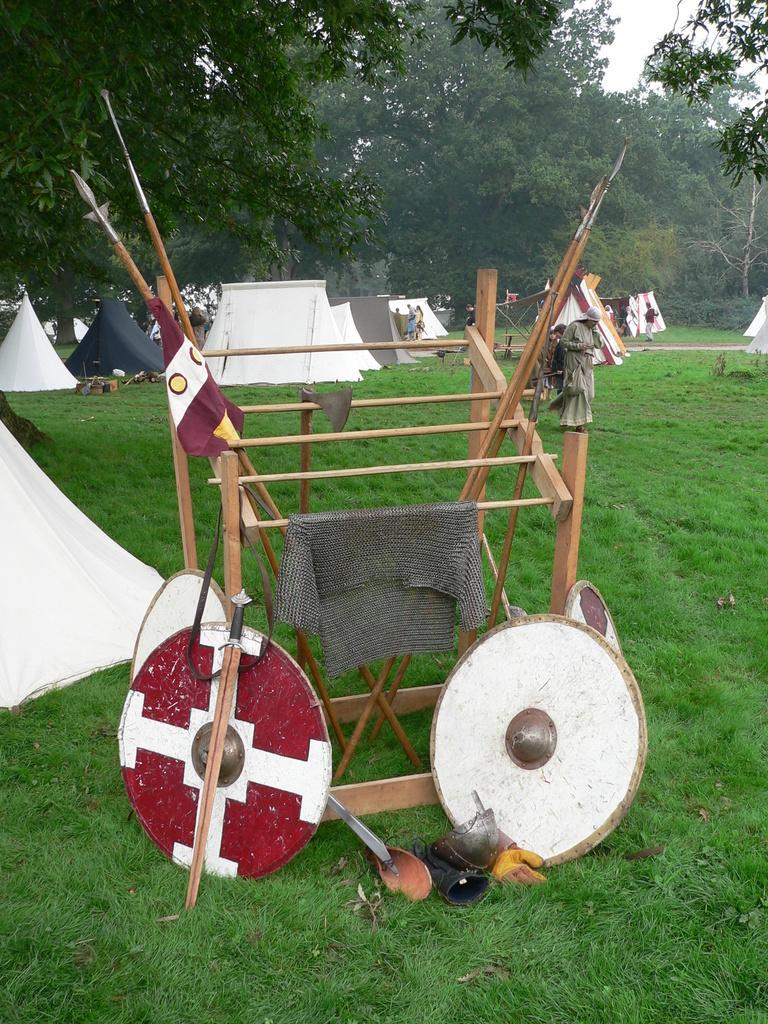In one or two sentences, can you explain what this image depicts? In this image there are tents on the ground. There is grass on the ground. In the foreground there is a wooden object. Near to it there are swords, shields and clothes. In the background there are trees. At the top there is the sky. 